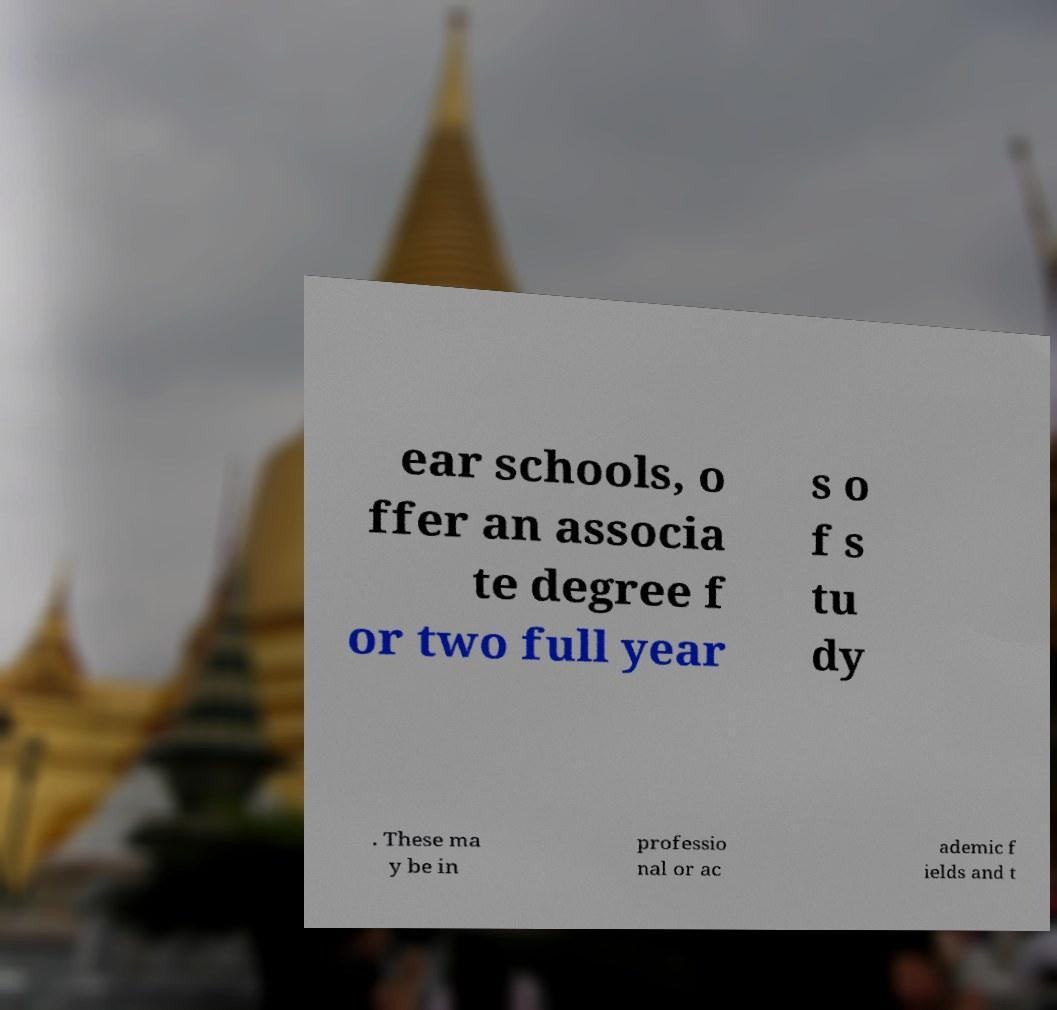Please identify and transcribe the text found in this image. ear schools, o ffer an associa te degree f or two full year s o f s tu dy . These ma y be in professio nal or ac ademic f ields and t 